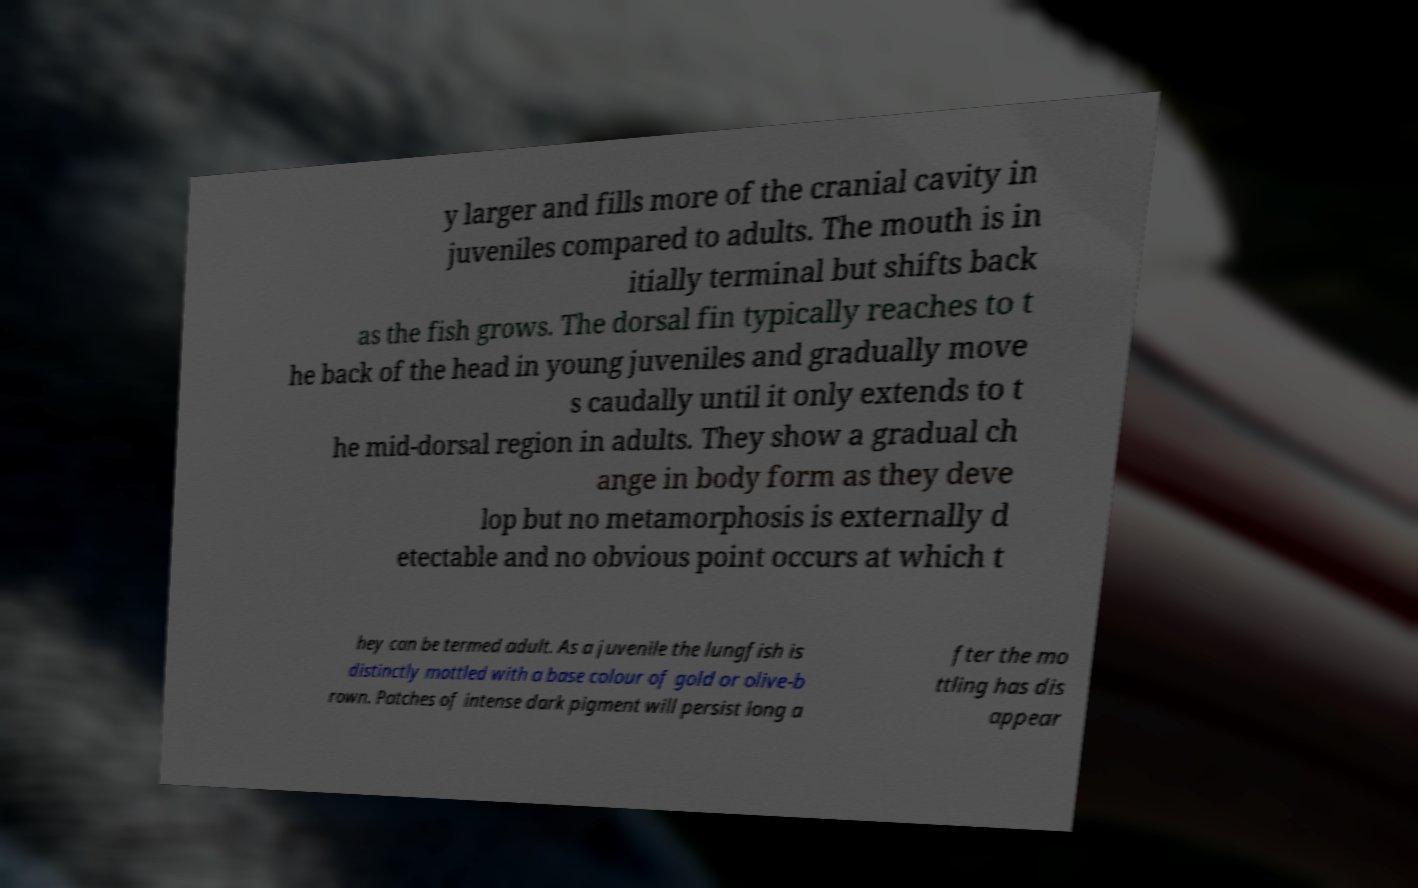I need the written content from this picture converted into text. Can you do that? y larger and fills more of the cranial cavity in juveniles compared to adults. The mouth is in itially terminal but shifts back as the fish grows. The dorsal fin typically reaches to t he back of the head in young juveniles and gradually move s caudally until it only extends to t he mid-dorsal region in adults. They show a gradual ch ange in body form as they deve lop but no metamorphosis is externally d etectable and no obvious point occurs at which t hey can be termed adult. As a juvenile the lungfish is distinctly mottled with a base colour of gold or olive-b rown. Patches of intense dark pigment will persist long a fter the mo ttling has dis appear 